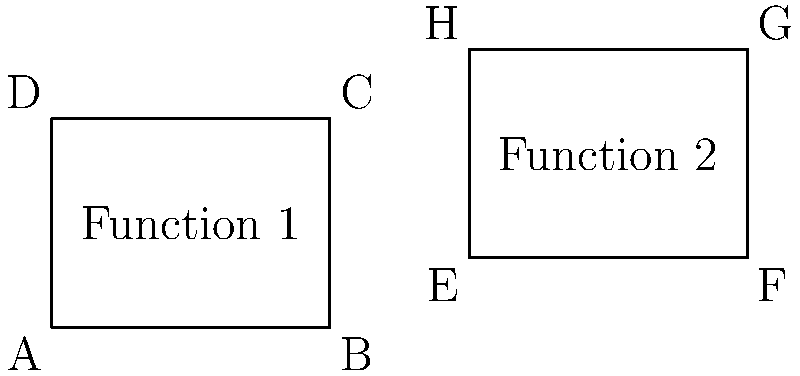In a script visualization tool, two polygons ABCD and EFGH represent different functions. If these polygons are congruent, what can we conclude about the functions they represent in the context of scripting languages? To answer this question, let's follow these steps:

1. Understand congruence: Two polygons are congruent if they have the same shape and size, meaning all corresponding sides and angles are equal.

2. Analyze the given polygons:
   - ABCD is a rectangle with width 4 units and height 3 units.
   - EFGH is also a rectangle with width 4 units and height 3 units.
   - Both polygons have the same shape (rectangle) and dimensions, so they are congruent.

3. Interpret the representation:
   - In scripting languages, functions are often represented visually to show their structure, complexity, or behavior.
   - Congruent polygons in this context would imply that the represented functions have identical characteristics in terms of the visualized aspects.

4. Consider scripting language context:
   - Functions in scripting languages can be compared based on various metrics such as:
     a) Number of lines of code
     b) Cyclomatic complexity
     c) Number of parameters
     d) Number of local variables
     e) Execution time
     f) Memory usage

5. Draw the conclusion:
   - Since the polygons are congruent, we can conclude that the functions they represent have identical characteristics in terms of the metrics being visualized.
   - This could mean that both functions have the same complexity, structure, or performance characteristics, depending on what the visualization tool is designed to represent.

Therefore, we can conclude that the two functions represented by the congruent polygons ABCD and EFGH are identical in terms of the characteristics being visualized by the script visualization tool.
Answer: The functions are identical in the visualized characteristics. 